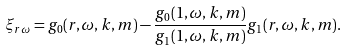<formula> <loc_0><loc_0><loc_500><loc_500>\xi _ { r \omega } = g _ { 0 } ( r , \omega , k , m ) - \frac { g _ { 0 } ( 1 , \omega , k , m ) } { g _ { 1 } ( 1 , \omega , k , m ) } g _ { 1 } ( r , \omega , k , m ) .</formula> 